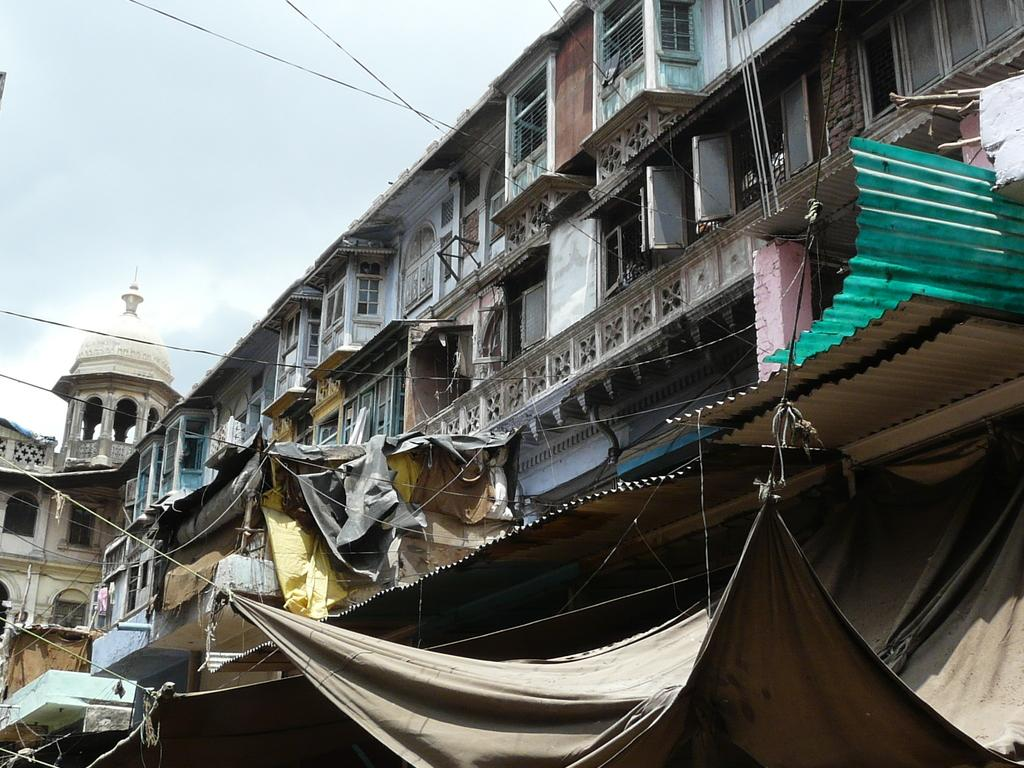What type of structure is visible in the image? There is a building in the image. What feature can be seen on the building? The building has windows. Is there any additional structure or object in the image? Yes, there is a tent in the bottom right corner of the image. How many trucks are parked near the building in the image? There are no trucks visible in the image; only the building and the tent are present. 